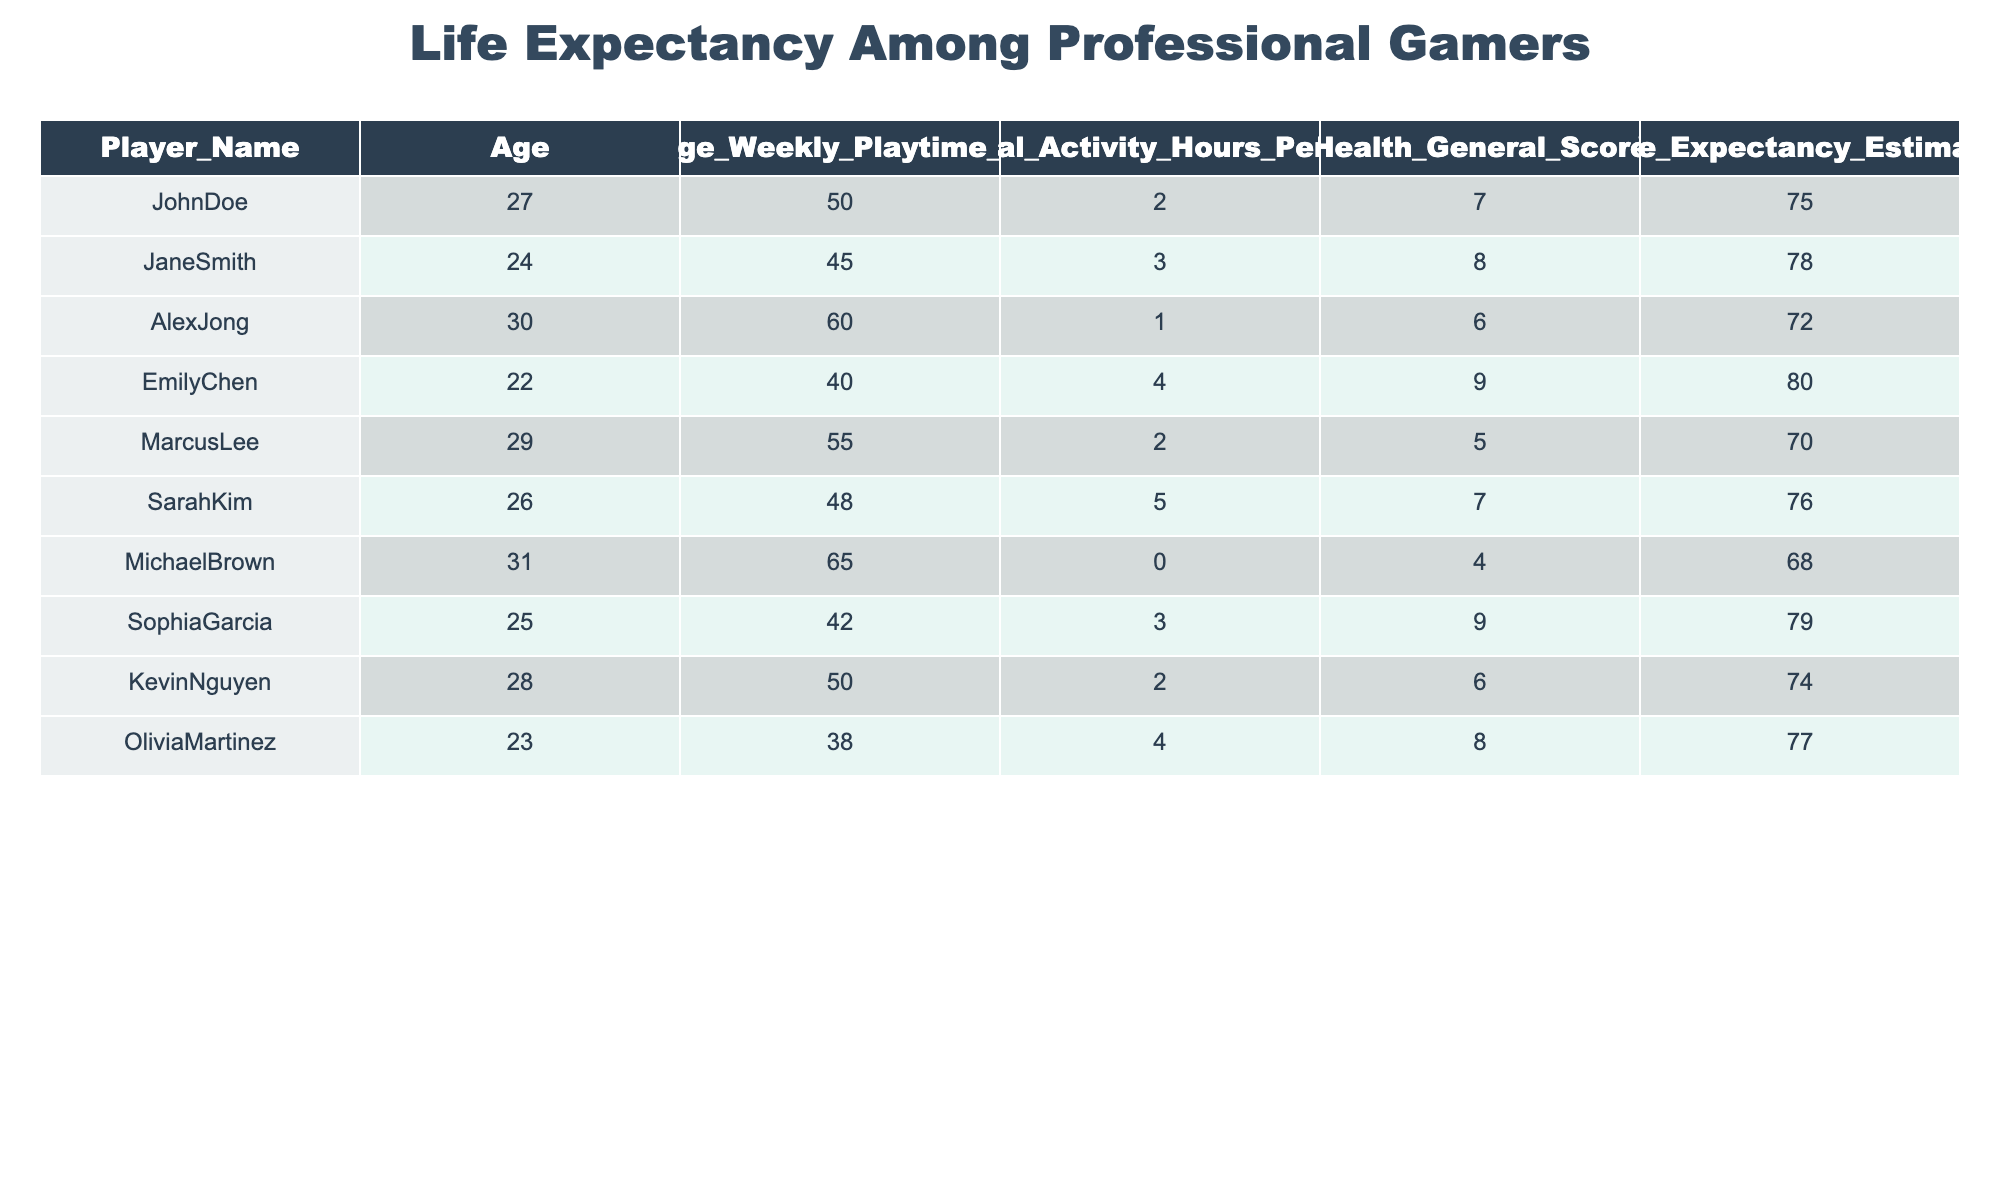What is the life expectancy estimate for Marcus Lee? The table shows the row for Marcus Lee, where the life expectancy estimate is explicitly listed next to his name.
Answer: 70 What are the health general scores for players younger than 25? Reviewing the ages in the table, the players younger than 25 are Emily Chen (22), Jane Smith (24), and Olivia Martinez (23). Their health general scores are 9, 8, and 8, respectively.
Answer: 9, 8, 8 Which player has the highest life expectancy and what is the value? The table must be assessed for the highest life expectancy estimate. Comparing all players, Emily Chen has the highest value, which is listed in her row.
Answer: 80 Is it true that John Doe plays more hours per week than Sophia Garcia? To evaluate this, we compare the average weekly playtime hours for both players. John Doe has 50 hours while Sophia Garcia has 42 hours, confirming that John Doe plays more.
Answer: Yes What is the average life expectancy of players who engage in physical activity for 4 hours or more per week? Players with 4 or more physical activity hours per week include Emily Chen (80), Olivia Martinez (77), and Sarah Kim (76). Adding these together gives 80 + 77 + 76 = 233. The average is then calculated by dividing the total by 3, leading to 233/3 = 77.67.
Answer: 77.67 How does the life expectancy of players who play more than 60 hours a week compare to those who play less? Players who play more than 60 hours a week are Michael Brown (68) and Alex Jong (72). Their average is (68 + 72) / 2 = 70. Meanwhile, averaging the life expectancy of players who play less than 60 hours gives 75, 78, 80, 76, 74, 79, and 77. The average for those less than 60 hours: 75 + 78 + 80 + 76 + 74 + 79 + 77 = 539, divided by 7 equals 76.71. Thus, those playing more than 60 hours have a lower life expectancy average of 70 compared to those with less, who average 76.71.
Answer: Lower Which players have both a health general score less than 7 and a life expectancy estimate above 75? Review the table for players meeting both criteria. Marcus Lee (5) and Michael Brown (4) have scores below 7. Among them, only John Doe (75) and Sarah Kim (76) have a life expectancy above 75. Therefore, no players meet both criteria.
Answer: No players meet both criteria 